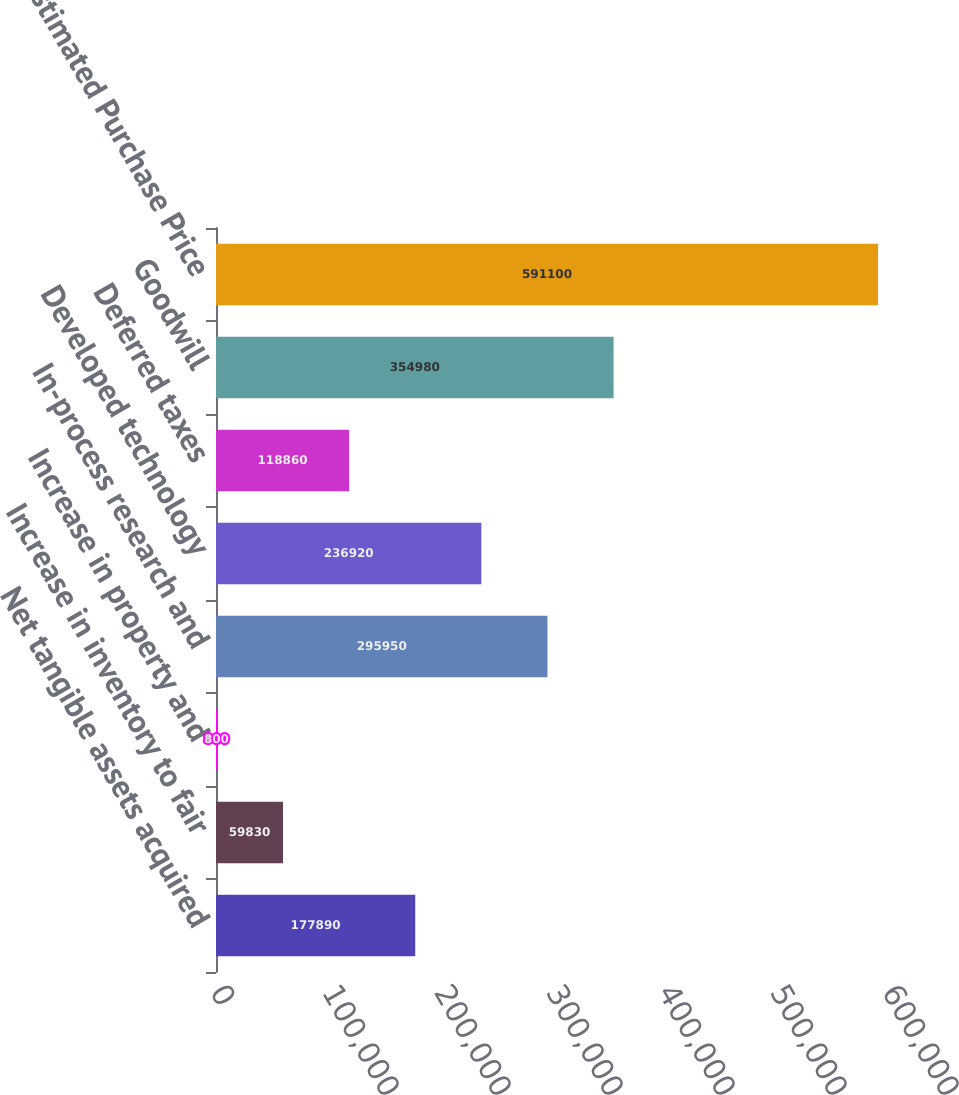Convert chart to OTSL. <chart><loc_0><loc_0><loc_500><loc_500><bar_chart><fcel>Net tangible assets acquired<fcel>Increase in inventory to fair<fcel>Increase in property and<fcel>In-process research and<fcel>Developed technology<fcel>Deferred taxes<fcel>Goodwill<fcel>Estimated Purchase Price<nl><fcel>177890<fcel>59830<fcel>800<fcel>295950<fcel>236920<fcel>118860<fcel>354980<fcel>591100<nl></chart> 